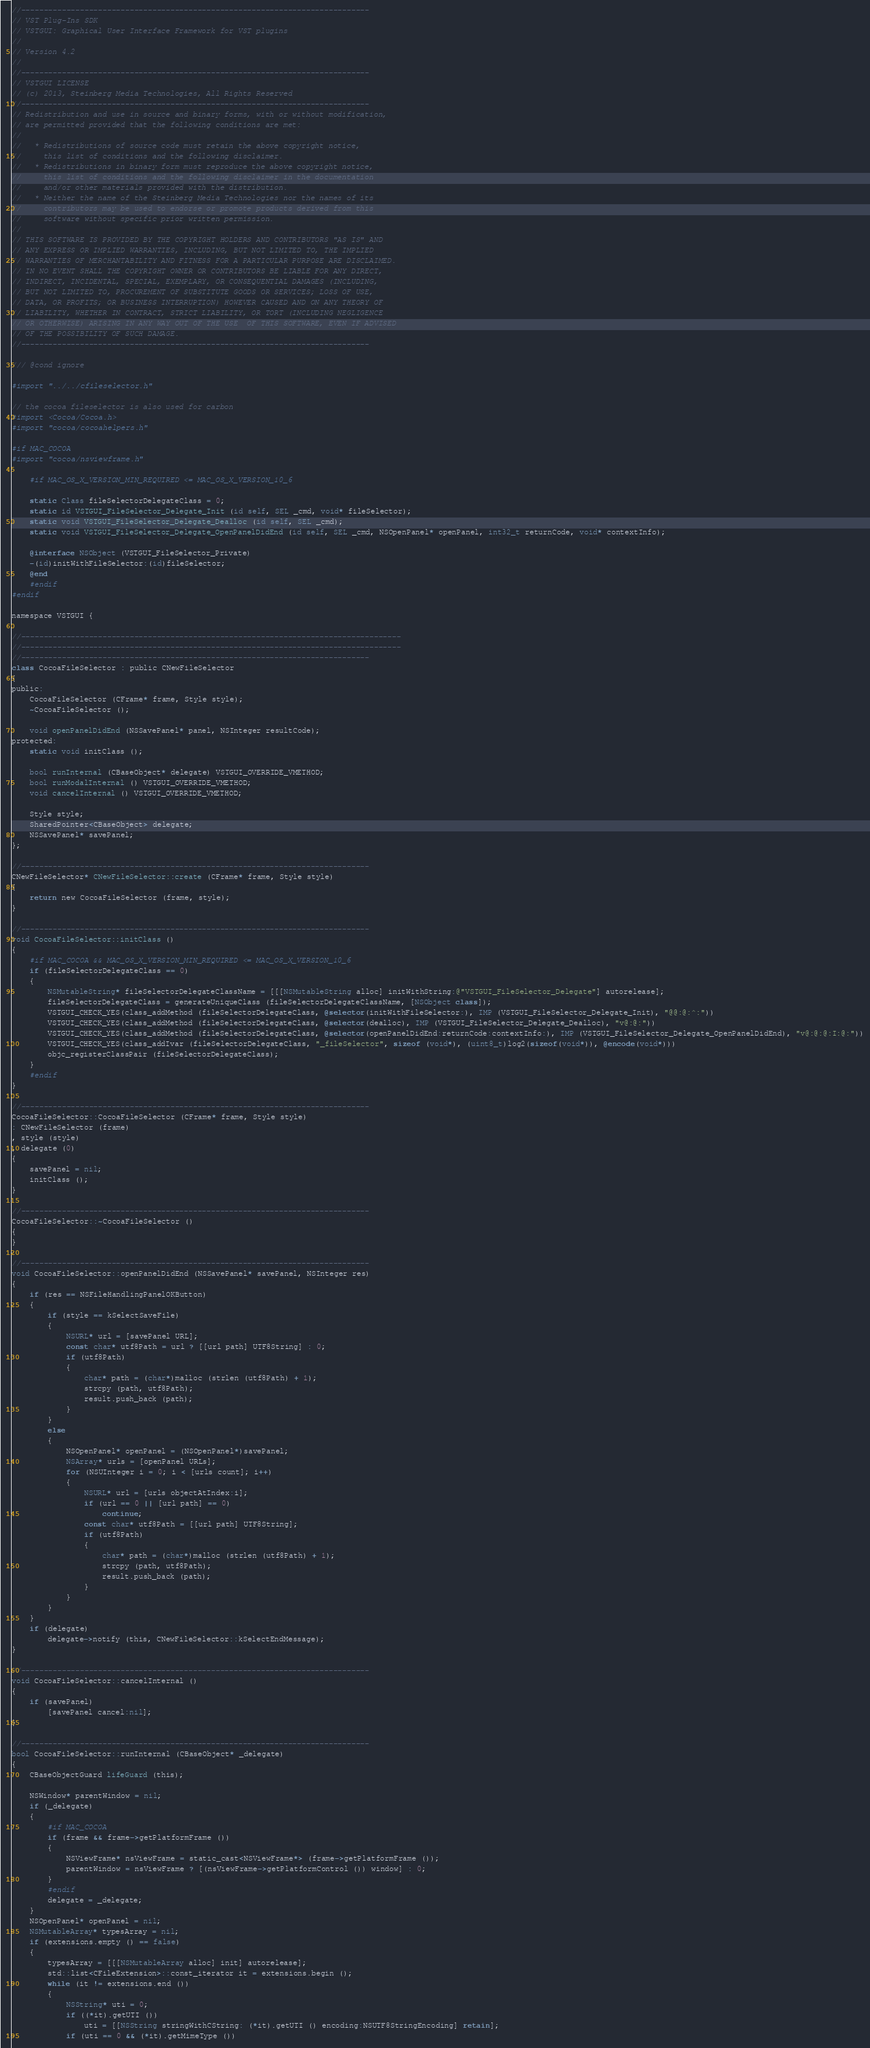Convert code to text. <code><loc_0><loc_0><loc_500><loc_500><_ObjectiveC_>//-----------------------------------------------------------------------------
// VST Plug-Ins SDK
// VSTGUI: Graphical User Interface Framework for VST plugins
//
// Version 4.2
//
//-----------------------------------------------------------------------------
// VSTGUI LICENSE
// (c) 2013, Steinberg Media Technologies, All Rights Reserved
//-----------------------------------------------------------------------------
// Redistribution and use in source and binary forms, with or without modification,
// are permitted provided that the following conditions are met:
// 
//   * Redistributions of source code must retain the above copyright notice, 
//     this list of conditions and the following disclaimer.
//   * Redistributions in binary form must reproduce the above copyright notice,
//     this list of conditions and the following disclaimer in the documentation 
//     and/or other materials provided with the distribution.
//   * Neither the name of the Steinberg Media Technologies nor the names of its
//     contributors may be used to endorse or promote products derived from this 
//     software without specific prior written permission.
// 
// THIS SOFTWARE IS PROVIDED BY THE COPYRIGHT HOLDERS AND CONTRIBUTORS "AS IS" AND
// ANY EXPRESS OR IMPLIED WARRANTIES, INCLUDING, BUT NOT LIMITED TO, THE IMPLIED 
// WARRANTIES OF MERCHANTABILITY AND FITNESS FOR A PARTICULAR PURPOSE ARE DISCLAIMED. 
// IN NO EVENT SHALL THE COPYRIGHT OWNER OR CONTRIBUTORS BE LIABLE FOR ANY DIRECT, 
// INDIRECT, INCIDENTAL, SPECIAL, EXEMPLARY, OR CONSEQUENTIAL DAMAGES (INCLUDING, 
// BUT NOT LIMITED TO, PROCUREMENT OF SUBSTITUTE GOODS OR SERVICES; LOSS OF USE, 
// DATA, OR PROFITS; OR BUSINESS INTERRUPTION) HOWEVER CAUSED AND ON ANY THEORY OF 
// LIABILITY, WHETHER IN CONTRACT, STRICT LIABILITY, OR TORT (INCLUDING NEGLIGENCE 
// OR OTHERWISE) ARISING IN ANY WAY OUT OF THE USE  OF THIS SOFTWARE, EVEN IF ADVISED
// OF THE POSSIBILITY OF SUCH DAMAGE.
//-----------------------------------------------------------------------------

/// @cond ignore

#import "../../cfileselector.h"

// the cocoa fileselector is also used for carbon
#import <Cocoa/Cocoa.h>
#import "cocoa/cocoahelpers.h"

#if MAC_COCOA
#import "cocoa/nsviewframe.h"

	#if MAC_OS_X_VERSION_MIN_REQUIRED <= MAC_OS_X_VERSION_10_6

	static Class fileSelectorDelegateClass = 0;
	static id VSTGUI_FileSelector_Delegate_Init (id self, SEL _cmd, void* fileSelector);
	static void VSTGUI_FileSelector_Delegate_Dealloc (id self, SEL _cmd);
	static void VSTGUI_FileSelector_Delegate_OpenPanelDidEnd (id self, SEL _cmd, NSOpenPanel* openPanel, int32_t returnCode, void* contextInfo);

	@interface NSObject (VSTGUI_FileSelector_Private)
	-(id)initWithFileSelector:(id)fileSelector;
	@end
	#endif
#endif

namespace VSTGUI {

//------------------------------------------------------------------------------------
//------------------------------------------------------------------------------------
//-----------------------------------------------------------------------------
class CocoaFileSelector : public CNewFileSelector
{
public:
	CocoaFileSelector (CFrame* frame, Style style);
	~CocoaFileSelector ();

	void openPanelDidEnd (NSSavePanel* panel, NSInteger resultCode);
protected:
	static void initClass ();
	
	bool runInternal (CBaseObject* delegate) VSTGUI_OVERRIDE_VMETHOD;
	bool runModalInternal () VSTGUI_OVERRIDE_VMETHOD;
	void cancelInternal () VSTGUI_OVERRIDE_VMETHOD;

	Style style;
	SharedPointer<CBaseObject> delegate;
	NSSavePanel* savePanel;
};

//-----------------------------------------------------------------------------
CNewFileSelector* CNewFileSelector::create (CFrame* frame, Style style)
{
	return new CocoaFileSelector (frame, style);
}

//-----------------------------------------------------------------------------
void CocoaFileSelector::initClass ()
{
	#if MAC_COCOA && MAC_OS_X_VERSION_MIN_REQUIRED <= MAC_OS_X_VERSION_10_6
	if (fileSelectorDelegateClass == 0)
	{
		NSMutableString* fileSelectorDelegateClassName = [[[NSMutableString alloc] initWithString:@"VSTGUI_FileSelector_Delegate"] autorelease];
		fileSelectorDelegateClass = generateUniqueClass (fileSelectorDelegateClassName, [NSObject class]);
		VSTGUI_CHECK_YES(class_addMethod (fileSelectorDelegateClass, @selector(initWithFileSelector:), IMP (VSTGUI_FileSelector_Delegate_Init), "@@:@:^:"))
		VSTGUI_CHECK_YES(class_addMethod (fileSelectorDelegateClass, @selector(dealloc), IMP (VSTGUI_FileSelector_Delegate_Dealloc), "v@:@:"))
		VSTGUI_CHECK_YES(class_addMethod (fileSelectorDelegateClass, @selector(openPanelDidEnd:returnCode:contextInfo:), IMP (VSTGUI_FileSelector_Delegate_OpenPanelDidEnd), "v@:@:@:I:@:"))
		VSTGUI_CHECK_YES(class_addIvar (fileSelectorDelegateClass, "_fileSelector", sizeof (void*), (uint8_t)log2(sizeof(void*)), @encode(void*)))
		objc_registerClassPair (fileSelectorDelegateClass);
	}
	#endif
}

//-----------------------------------------------------------------------------
CocoaFileSelector::CocoaFileSelector (CFrame* frame, Style style)
: CNewFileSelector (frame)
, style (style)
, delegate (0)
{
	savePanel = nil;
	initClass ();
}

//-----------------------------------------------------------------------------
CocoaFileSelector::~CocoaFileSelector ()
{
}

//-----------------------------------------------------------------------------
void CocoaFileSelector::openPanelDidEnd (NSSavePanel* savePanel, NSInteger res)
{
	if (res == NSFileHandlingPanelOKButton)
	{
		if (style == kSelectSaveFile)
		{
			NSURL* url = [savePanel URL];
			const char* utf8Path = url ? [[url path] UTF8String] : 0;
			if (utf8Path)
			{
				char* path = (char*)malloc (strlen (utf8Path) + 1);
				strcpy (path, utf8Path);
				result.push_back (path);
			}
		}
		else
		{
			NSOpenPanel* openPanel = (NSOpenPanel*)savePanel;
			NSArray* urls = [openPanel URLs];
			for (NSUInteger i = 0; i < [urls count]; i++)
			{
				NSURL* url = [urls objectAtIndex:i];
				if (url == 0 || [url path] == 0)
					continue;
				const char* utf8Path = [[url path] UTF8String];
				if (utf8Path)
				{
					char* path = (char*)malloc (strlen (utf8Path) + 1);
					strcpy (path, utf8Path);
					result.push_back (path);
				}
			}
		}
	}
	if (delegate)
		delegate->notify (this, CNewFileSelector::kSelectEndMessage);
}

//-----------------------------------------------------------------------------
void CocoaFileSelector::cancelInternal ()
{
	if (savePanel)
		[savePanel cancel:nil];
}

//-----------------------------------------------------------------------------
bool CocoaFileSelector::runInternal (CBaseObject* _delegate)
{
	CBaseObjectGuard lifeGuard (this);

	NSWindow* parentWindow = nil;
	if (_delegate)
	{
		#if MAC_COCOA
		if (frame && frame->getPlatformFrame ())
		{
			NSViewFrame* nsViewFrame = static_cast<NSViewFrame*> (frame->getPlatformFrame ());
			parentWindow = nsViewFrame ? [(nsViewFrame->getPlatformControl ()) window] : 0;
		}
		#endif
		delegate = _delegate;
	}
	NSOpenPanel* openPanel = nil;
	NSMutableArray* typesArray = nil;
	if (extensions.empty () == false)
	{
		typesArray = [[[NSMutableArray alloc] init] autorelease];
		std::list<CFileExtension>::const_iterator it = extensions.begin ();
		while (it != extensions.end ())
		{
			NSString* uti = 0;
			if ((*it).getUTI ())
				uti = [[NSString stringWithCString: (*it).getUTI () encoding:NSUTF8StringEncoding] retain];
			if (uti == 0 && (*it).getMimeType ())</code> 